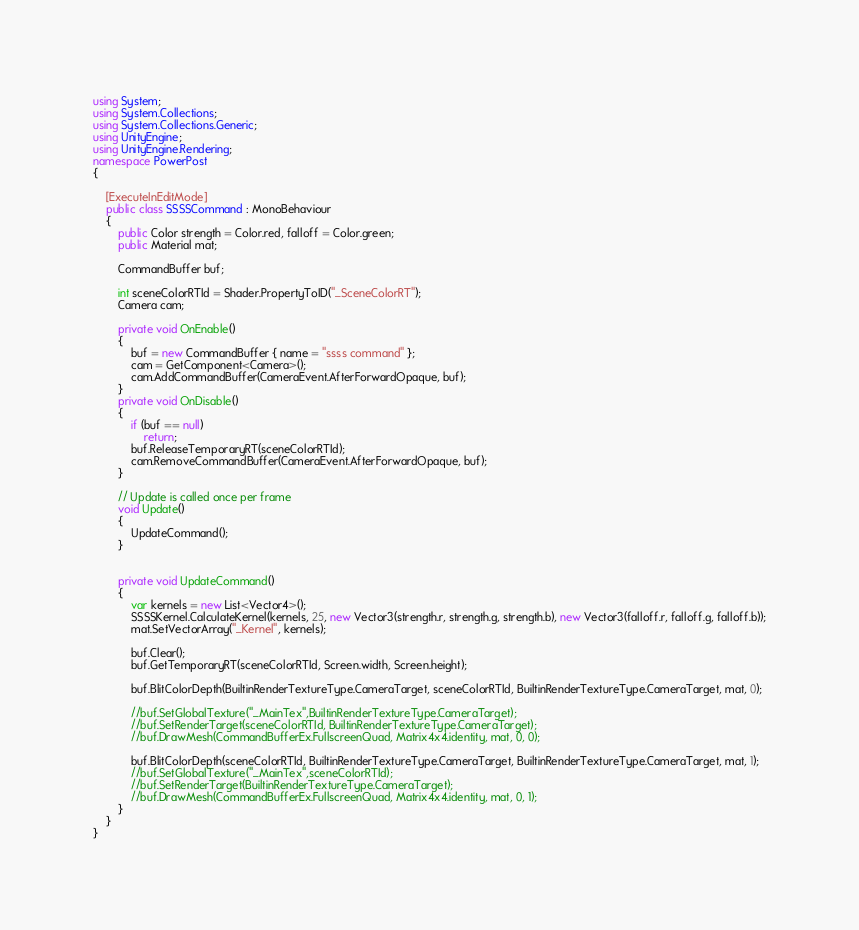<code> <loc_0><loc_0><loc_500><loc_500><_C#_>using System;
using System.Collections;
using System.Collections.Generic;
using UnityEngine;
using UnityEngine.Rendering;
namespace PowerPost
{

    [ExecuteInEditMode]
    public class SSSSCommand : MonoBehaviour
    {
        public Color strength = Color.red, falloff = Color.green;
        public Material mat;

        CommandBuffer buf;

        int sceneColorRTId = Shader.PropertyToID("_SceneColorRT");
        Camera cam;

        private void OnEnable()
        {
            buf = new CommandBuffer { name = "ssss command" };
            cam = GetComponent<Camera>();
            cam.AddCommandBuffer(CameraEvent.AfterForwardOpaque, buf);
        }
        private void OnDisable()
        {
            if (buf == null)
                return;
            buf.ReleaseTemporaryRT(sceneColorRTId);
            cam.RemoveCommandBuffer(CameraEvent.AfterForwardOpaque, buf);
        }

        // Update is called once per frame
        void Update()
        {
            UpdateCommand();
        }


        private void UpdateCommand()
        {
            var kernels = new List<Vector4>();
            SSSSKernel.CalculateKernel(kernels, 25, new Vector3(strength.r, strength.g, strength.b), new Vector3(falloff.r, falloff.g, falloff.b));
            mat.SetVectorArray("_Kernel", kernels);

            buf.Clear();
            buf.GetTemporaryRT(sceneColorRTId, Screen.width, Screen.height);

            buf.BlitColorDepth(BuiltinRenderTextureType.CameraTarget, sceneColorRTId, BuiltinRenderTextureType.CameraTarget, mat, 0);

            //buf.SetGlobalTexture("_MainTex",BuiltinRenderTextureType.CameraTarget);
            //buf.SetRenderTarget(sceneColorRTId, BuiltinRenderTextureType.CameraTarget);
            //buf.DrawMesh(CommandBufferEx.FullscreenQuad, Matrix4x4.identity, mat, 0, 0);

            buf.BlitColorDepth(sceneColorRTId, BuiltinRenderTextureType.CameraTarget, BuiltinRenderTextureType.CameraTarget, mat, 1);
            //buf.SetGlobalTexture("_MainTex",sceneColorRTId);
            //buf.SetRenderTarget(BuiltinRenderTextureType.CameraTarget);
            //buf.DrawMesh(CommandBufferEx.FullscreenQuad, Matrix4x4.identity, mat, 0, 1);
        }
    }
}</code> 